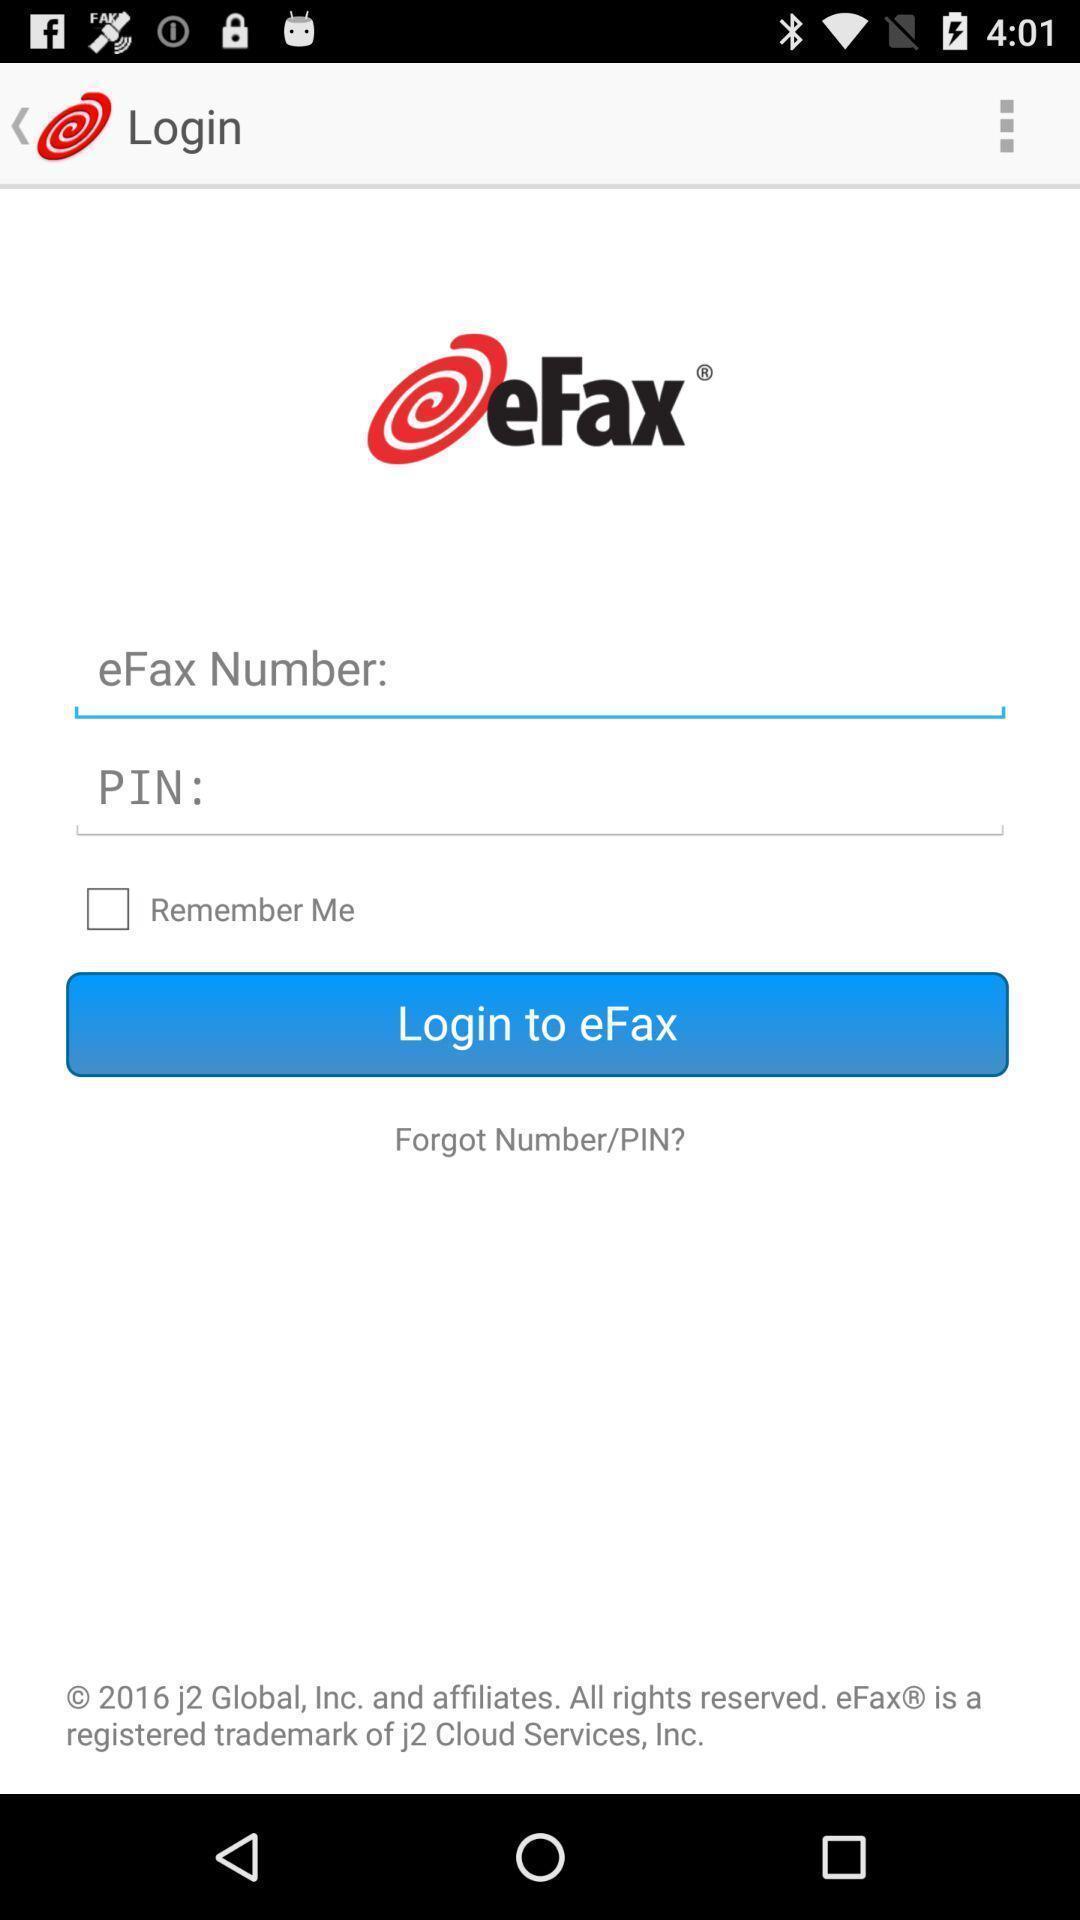Summarize the information in this screenshot. Login page. 